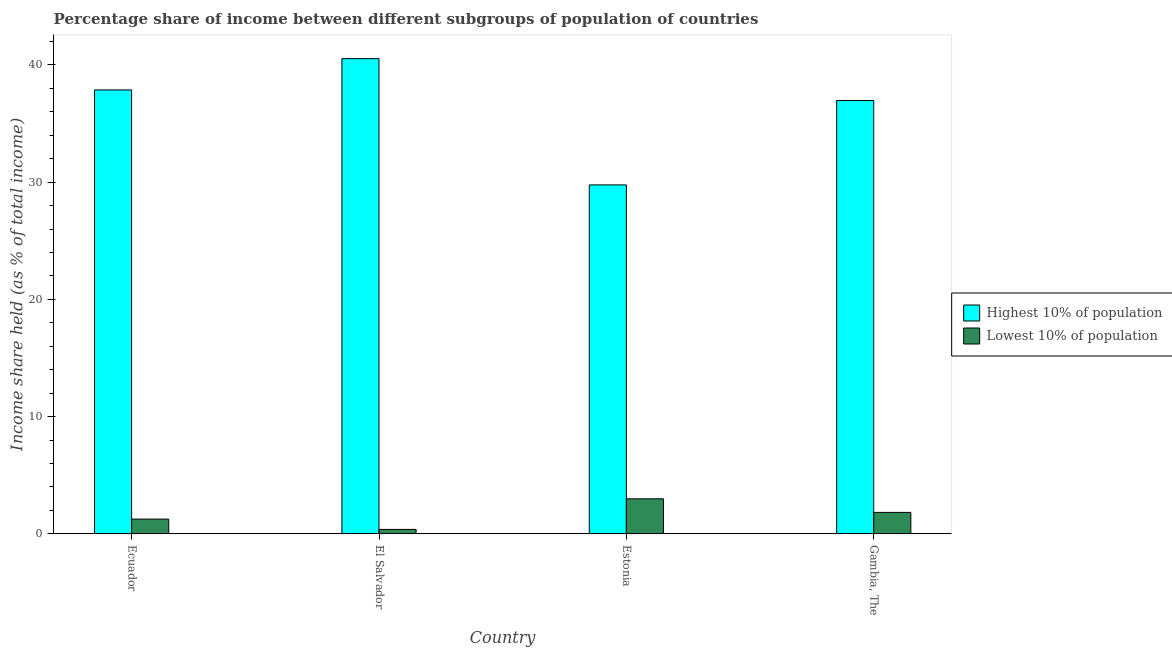How many different coloured bars are there?
Make the answer very short. 2. How many groups of bars are there?
Ensure brevity in your answer.  4. Are the number of bars per tick equal to the number of legend labels?
Provide a succinct answer. Yes. Are the number of bars on each tick of the X-axis equal?
Offer a very short reply. Yes. What is the label of the 2nd group of bars from the left?
Your response must be concise. El Salvador. In how many cases, is the number of bars for a given country not equal to the number of legend labels?
Give a very brief answer. 0. What is the income share held by lowest 10% of the population in Ecuador?
Your answer should be very brief. 1.26. Across all countries, what is the maximum income share held by lowest 10% of the population?
Provide a succinct answer. 2.99. Across all countries, what is the minimum income share held by lowest 10% of the population?
Offer a terse response. 0.38. In which country was the income share held by lowest 10% of the population maximum?
Ensure brevity in your answer.  Estonia. In which country was the income share held by lowest 10% of the population minimum?
Keep it short and to the point. El Salvador. What is the total income share held by highest 10% of the population in the graph?
Your answer should be compact. 145.11. What is the difference between the income share held by lowest 10% of the population in Ecuador and that in Estonia?
Offer a very short reply. -1.73. What is the difference between the income share held by lowest 10% of the population in Estonia and the income share held by highest 10% of the population in Gambia, The?
Offer a terse response. -33.97. What is the average income share held by highest 10% of the population per country?
Ensure brevity in your answer.  36.28. What is the difference between the income share held by highest 10% of the population and income share held by lowest 10% of the population in Estonia?
Provide a short and direct response. 26.77. What is the ratio of the income share held by lowest 10% of the population in Ecuador to that in El Salvador?
Offer a very short reply. 3.32. Is the income share held by lowest 10% of the population in Ecuador less than that in Gambia, The?
Provide a succinct answer. Yes. What is the difference between the highest and the second highest income share held by lowest 10% of the population?
Make the answer very short. 1.16. What is the difference between the highest and the lowest income share held by lowest 10% of the population?
Your response must be concise. 2.61. In how many countries, is the income share held by highest 10% of the population greater than the average income share held by highest 10% of the population taken over all countries?
Provide a short and direct response. 3. What does the 1st bar from the left in Gambia, The represents?
Make the answer very short. Highest 10% of population. What does the 2nd bar from the right in Ecuador represents?
Ensure brevity in your answer.  Highest 10% of population. How many bars are there?
Ensure brevity in your answer.  8. How many countries are there in the graph?
Your answer should be compact. 4. Are the values on the major ticks of Y-axis written in scientific E-notation?
Keep it short and to the point. No. Does the graph contain any zero values?
Make the answer very short. No. Does the graph contain grids?
Your answer should be very brief. No. How are the legend labels stacked?
Give a very brief answer. Vertical. What is the title of the graph?
Your answer should be compact. Percentage share of income between different subgroups of population of countries. Does "Secondary Education" appear as one of the legend labels in the graph?
Give a very brief answer. No. What is the label or title of the Y-axis?
Ensure brevity in your answer.  Income share held (as % of total income). What is the Income share held (as % of total income) of Highest 10% of population in Ecuador?
Keep it short and to the point. 37.86. What is the Income share held (as % of total income) in Lowest 10% of population in Ecuador?
Make the answer very short. 1.26. What is the Income share held (as % of total income) of Highest 10% of population in El Salvador?
Offer a terse response. 40.53. What is the Income share held (as % of total income) in Lowest 10% of population in El Salvador?
Provide a succinct answer. 0.38. What is the Income share held (as % of total income) in Highest 10% of population in Estonia?
Your answer should be compact. 29.76. What is the Income share held (as % of total income) of Lowest 10% of population in Estonia?
Offer a terse response. 2.99. What is the Income share held (as % of total income) in Highest 10% of population in Gambia, The?
Offer a very short reply. 36.96. What is the Income share held (as % of total income) of Lowest 10% of population in Gambia, The?
Your answer should be very brief. 1.83. Across all countries, what is the maximum Income share held (as % of total income) in Highest 10% of population?
Provide a succinct answer. 40.53. Across all countries, what is the maximum Income share held (as % of total income) in Lowest 10% of population?
Your answer should be compact. 2.99. Across all countries, what is the minimum Income share held (as % of total income) of Highest 10% of population?
Your answer should be compact. 29.76. Across all countries, what is the minimum Income share held (as % of total income) in Lowest 10% of population?
Keep it short and to the point. 0.38. What is the total Income share held (as % of total income) in Highest 10% of population in the graph?
Provide a succinct answer. 145.11. What is the total Income share held (as % of total income) in Lowest 10% of population in the graph?
Keep it short and to the point. 6.46. What is the difference between the Income share held (as % of total income) in Highest 10% of population in Ecuador and that in El Salvador?
Your response must be concise. -2.67. What is the difference between the Income share held (as % of total income) of Lowest 10% of population in Ecuador and that in Estonia?
Your response must be concise. -1.73. What is the difference between the Income share held (as % of total income) in Highest 10% of population in Ecuador and that in Gambia, The?
Your answer should be very brief. 0.9. What is the difference between the Income share held (as % of total income) in Lowest 10% of population in Ecuador and that in Gambia, The?
Give a very brief answer. -0.57. What is the difference between the Income share held (as % of total income) in Highest 10% of population in El Salvador and that in Estonia?
Keep it short and to the point. 10.77. What is the difference between the Income share held (as % of total income) in Lowest 10% of population in El Salvador and that in Estonia?
Provide a short and direct response. -2.61. What is the difference between the Income share held (as % of total income) in Highest 10% of population in El Salvador and that in Gambia, The?
Offer a very short reply. 3.57. What is the difference between the Income share held (as % of total income) of Lowest 10% of population in El Salvador and that in Gambia, The?
Keep it short and to the point. -1.45. What is the difference between the Income share held (as % of total income) of Highest 10% of population in Estonia and that in Gambia, The?
Your answer should be very brief. -7.2. What is the difference between the Income share held (as % of total income) of Lowest 10% of population in Estonia and that in Gambia, The?
Your response must be concise. 1.16. What is the difference between the Income share held (as % of total income) in Highest 10% of population in Ecuador and the Income share held (as % of total income) in Lowest 10% of population in El Salvador?
Provide a short and direct response. 37.48. What is the difference between the Income share held (as % of total income) of Highest 10% of population in Ecuador and the Income share held (as % of total income) of Lowest 10% of population in Estonia?
Offer a very short reply. 34.87. What is the difference between the Income share held (as % of total income) in Highest 10% of population in Ecuador and the Income share held (as % of total income) in Lowest 10% of population in Gambia, The?
Your response must be concise. 36.03. What is the difference between the Income share held (as % of total income) of Highest 10% of population in El Salvador and the Income share held (as % of total income) of Lowest 10% of population in Estonia?
Your answer should be compact. 37.54. What is the difference between the Income share held (as % of total income) in Highest 10% of population in El Salvador and the Income share held (as % of total income) in Lowest 10% of population in Gambia, The?
Give a very brief answer. 38.7. What is the difference between the Income share held (as % of total income) in Highest 10% of population in Estonia and the Income share held (as % of total income) in Lowest 10% of population in Gambia, The?
Offer a terse response. 27.93. What is the average Income share held (as % of total income) in Highest 10% of population per country?
Your response must be concise. 36.28. What is the average Income share held (as % of total income) in Lowest 10% of population per country?
Ensure brevity in your answer.  1.61. What is the difference between the Income share held (as % of total income) in Highest 10% of population and Income share held (as % of total income) in Lowest 10% of population in Ecuador?
Provide a short and direct response. 36.6. What is the difference between the Income share held (as % of total income) in Highest 10% of population and Income share held (as % of total income) in Lowest 10% of population in El Salvador?
Provide a short and direct response. 40.15. What is the difference between the Income share held (as % of total income) in Highest 10% of population and Income share held (as % of total income) in Lowest 10% of population in Estonia?
Provide a succinct answer. 26.77. What is the difference between the Income share held (as % of total income) in Highest 10% of population and Income share held (as % of total income) in Lowest 10% of population in Gambia, The?
Offer a very short reply. 35.13. What is the ratio of the Income share held (as % of total income) of Highest 10% of population in Ecuador to that in El Salvador?
Give a very brief answer. 0.93. What is the ratio of the Income share held (as % of total income) of Lowest 10% of population in Ecuador to that in El Salvador?
Your answer should be very brief. 3.32. What is the ratio of the Income share held (as % of total income) of Highest 10% of population in Ecuador to that in Estonia?
Your answer should be very brief. 1.27. What is the ratio of the Income share held (as % of total income) of Lowest 10% of population in Ecuador to that in Estonia?
Make the answer very short. 0.42. What is the ratio of the Income share held (as % of total income) of Highest 10% of population in Ecuador to that in Gambia, The?
Your answer should be compact. 1.02. What is the ratio of the Income share held (as % of total income) of Lowest 10% of population in Ecuador to that in Gambia, The?
Offer a terse response. 0.69. What is the ratio of the Income share held (as % of total income) in Highest 10% of population in El Salvador to that in Estonia?
Your response must be concise. 1.36. What is the ratio of the Income share held (as % of total income) in Lowest 10% of population in El Salvador to that in Estonia?
Provide a short and direct response. 0.13. What is the ratio of the Income share held (as % of total income) of Highest 10% of population in El Salvador to that in Gambia, The?
Ensure brevity in your answer.  1.1. What is the ratio of the Income share held (as % of total income) in Lowest 10% of population in El Salvador to that in Gambia, The?
Offer a terse response. 0.21. What is the ratio of the Income share held (as % of total income) of Highest 10% of population in Estonia to that in Gambia, The?
Provide a succinct answer. 0.81. What is the ratio of the Income share held (as % of total income) of Lowest 10% of population in Estonia to that in Gambia, The?
Your response must be concise. 1.63. What is the difference between the highest and the second highest Income share held (as % of total income) in Highest 10% of population?
Keep it short and to the point. 2.67. What is the difference between the highest and the second highest Income share held (as % of total income) in Lowest 10% of population?
Provide a succinct answer. 1.16. What is the difference between the highest and the lowest Income share held (as % of total income) in Highest 10% of population?
Keep it short and to the point. 10.77. What is the difference between the highest and the lowest Income share held (as % of total income) of Lowest 10% of population?
Provide a succinct answer. 2.61. 